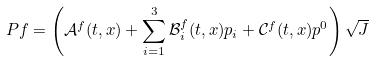<formula> <loc_0><loc_0><loc_500><loc_500>P f = \left ( \mathcal { A } ^ { f } ( t , x ) + \sum _ { i = 1 } ^ { 3 } \mathcal { B } ^ { f } _ { i } ( t , x ) p _ { i } + \mathcal { C } ^ { f } ( t , x ) { p ^ { 0 } } \right ) \sqrt { J }</formula> 